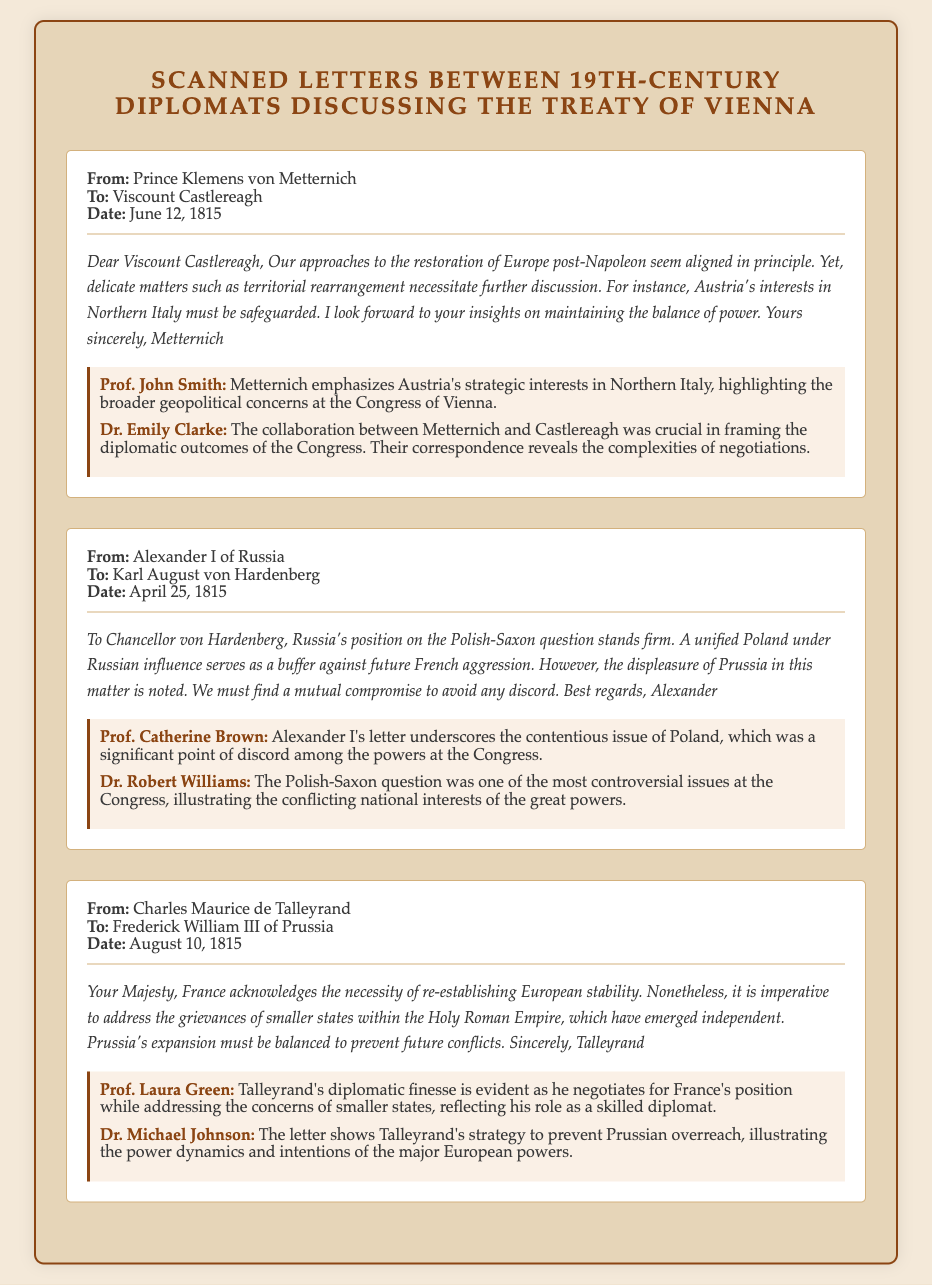what is the date of the letter from Metternich to Castlereagh? The letter from Metternich to Castlereagh is dated June 12, 1815.
Answer: June 12, 1815 who wrote to Frederick William III of Prussia? The letter was written by Charles Maurice de Talleyrand.
Answer: Charles Maurice de Talleyrand what is the primary topic discussed in Alexander I's letter? Alexander I's letter discusses the Polish-Saxon question and Russian interests.
Answer: Polish-Saxon question which diplomat emphasizes Austria's interests in Northern Italy? Prince Klemens von Metternich emphasizes Austria's interests.
Answer: Prince Klemens von Metternich what is a central theme in Talleyrand's correspondence? A central theme is balancing Prussia's expansion and the grievances of smaller states.
Answer: Balancing Prussia's expansion who corresponds with Karl August von Hardenberg? Alexander I of Russia corresponds with Karl August von Hardenberg.
Answer: Alexander I of Russia what is the nature of the relationship between Metternich and Castlereagh as indicated in the document? The relationship is collaborative, focused on maintaining the balance of power in Europe.
Answer: Collaborative which country is highlighted as having interests regarding Polish matters? Russia is highlighted as having interests regarding Polish matters.
Answer: Russia how many letters are included in the document? There are three letters included in the document.
Answer: Three 